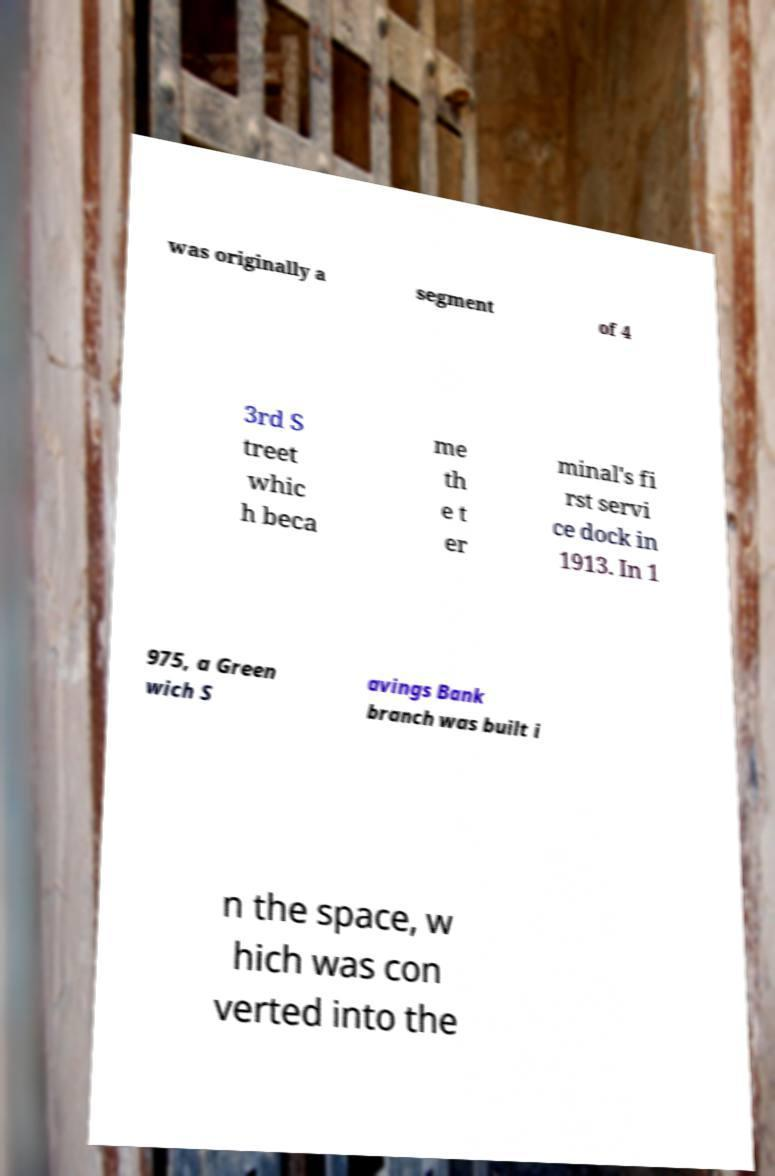Please identify and transcribe the text found in this image. was originally a segment of 4 3rd S treet whic h beca me th e t er minal's fi rst servi ce dock in 1913. In 1 975, a Green wich S avings Bank branch was built i n the space, w hich was con verted into the 